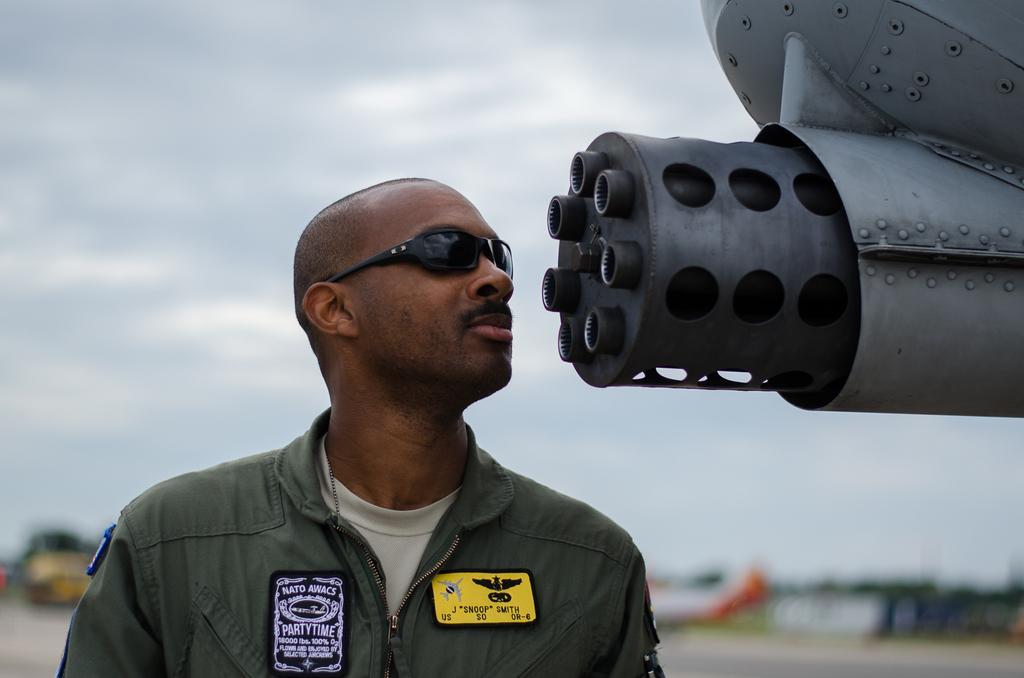How would you summarize this image in a sentence or two? In this picture we can see a person, he is wearing a goggles, here we can see an object, at the back of him we can see some objects and it is blurry and we can see sky in the background. 